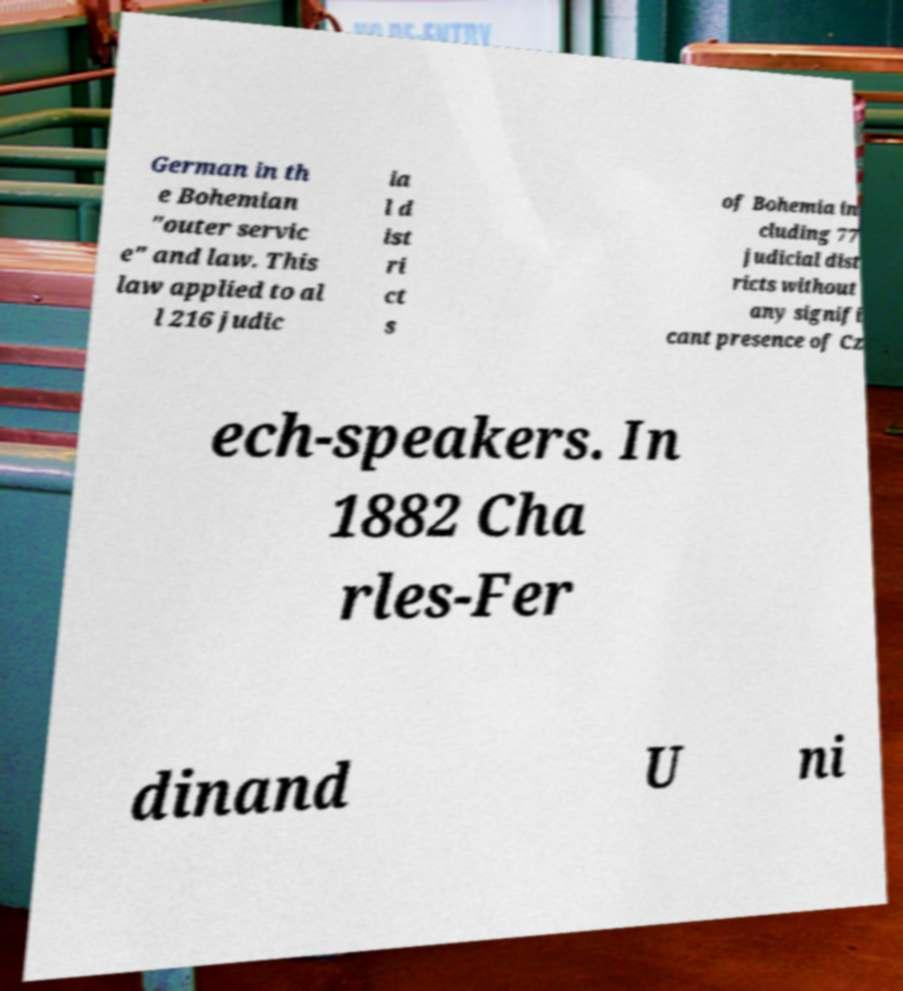There's text embedded in this image that I need extracted. Can you transcribe it verbatim? German in th e Bohemian "outer servic e" and law. This law applied to al l 216 judic ia l d ist ri ct s of Bohemia in cluding 77 judicial dist ricts without any signifi cant presence of Cz ech-speakers. In 1882 Cha rles-Fer dinand U ni 